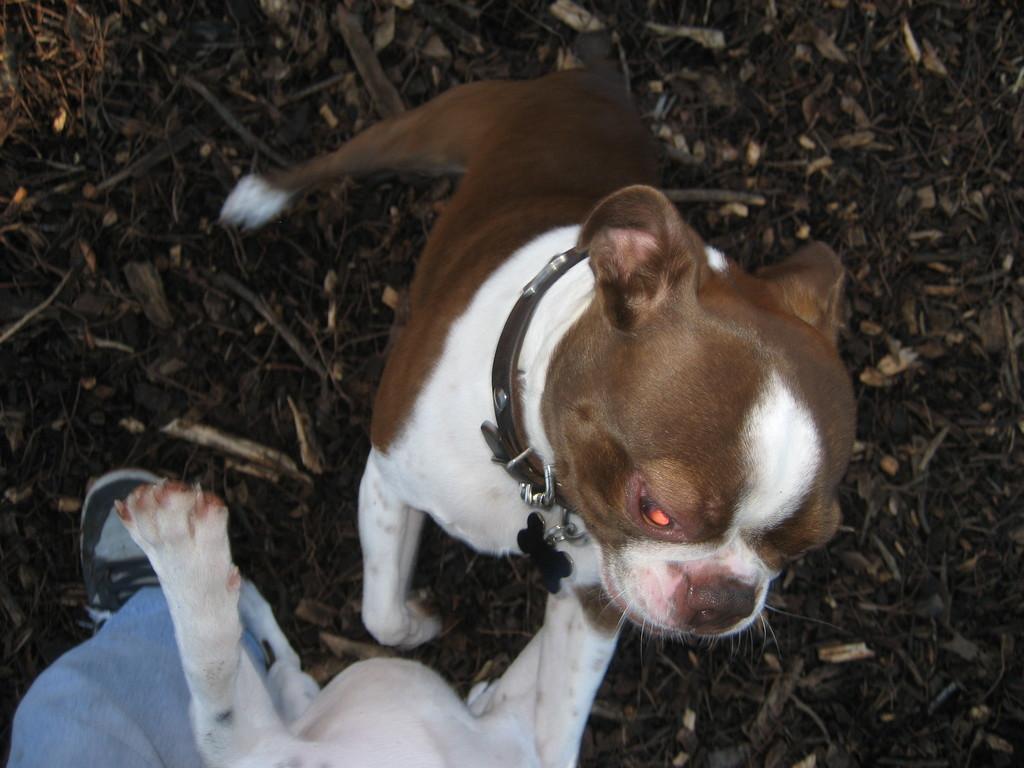Please provide a concise description of this image. In the image we can see there are dogs standing on the ground and there is a person. 